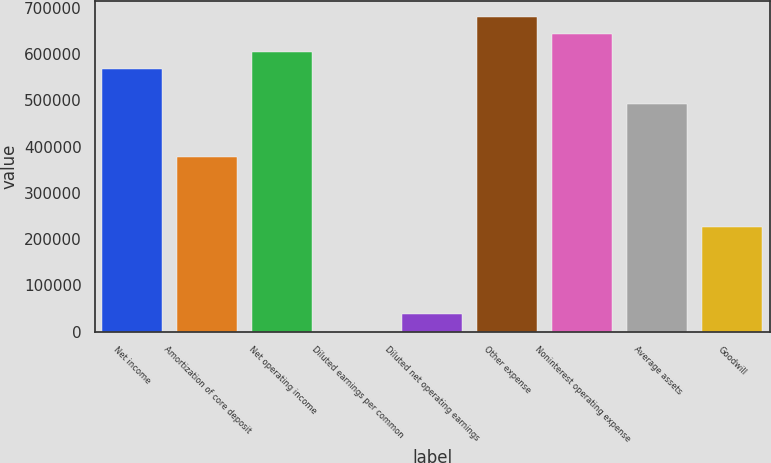<chart> <loc_0><loc_0><loc_500><loc_500><bar_chart><fcel>Net income<fcel>Amortization of core deposit<fcel>Net operating income<fcel>Diluted earnings per common<fcel>Diluted net operating earnings<fcel>Other expense<fcel>Noninterest operating expense<fcel>Average assets<fcel>Goodwill<nl><fcel>567532<fcel>378355<fcel>605367<fcel>1.35<fcel>37836.7<fcel>681038<fcel>643203<fcel>491861<fcel>227014<nl></chart> 